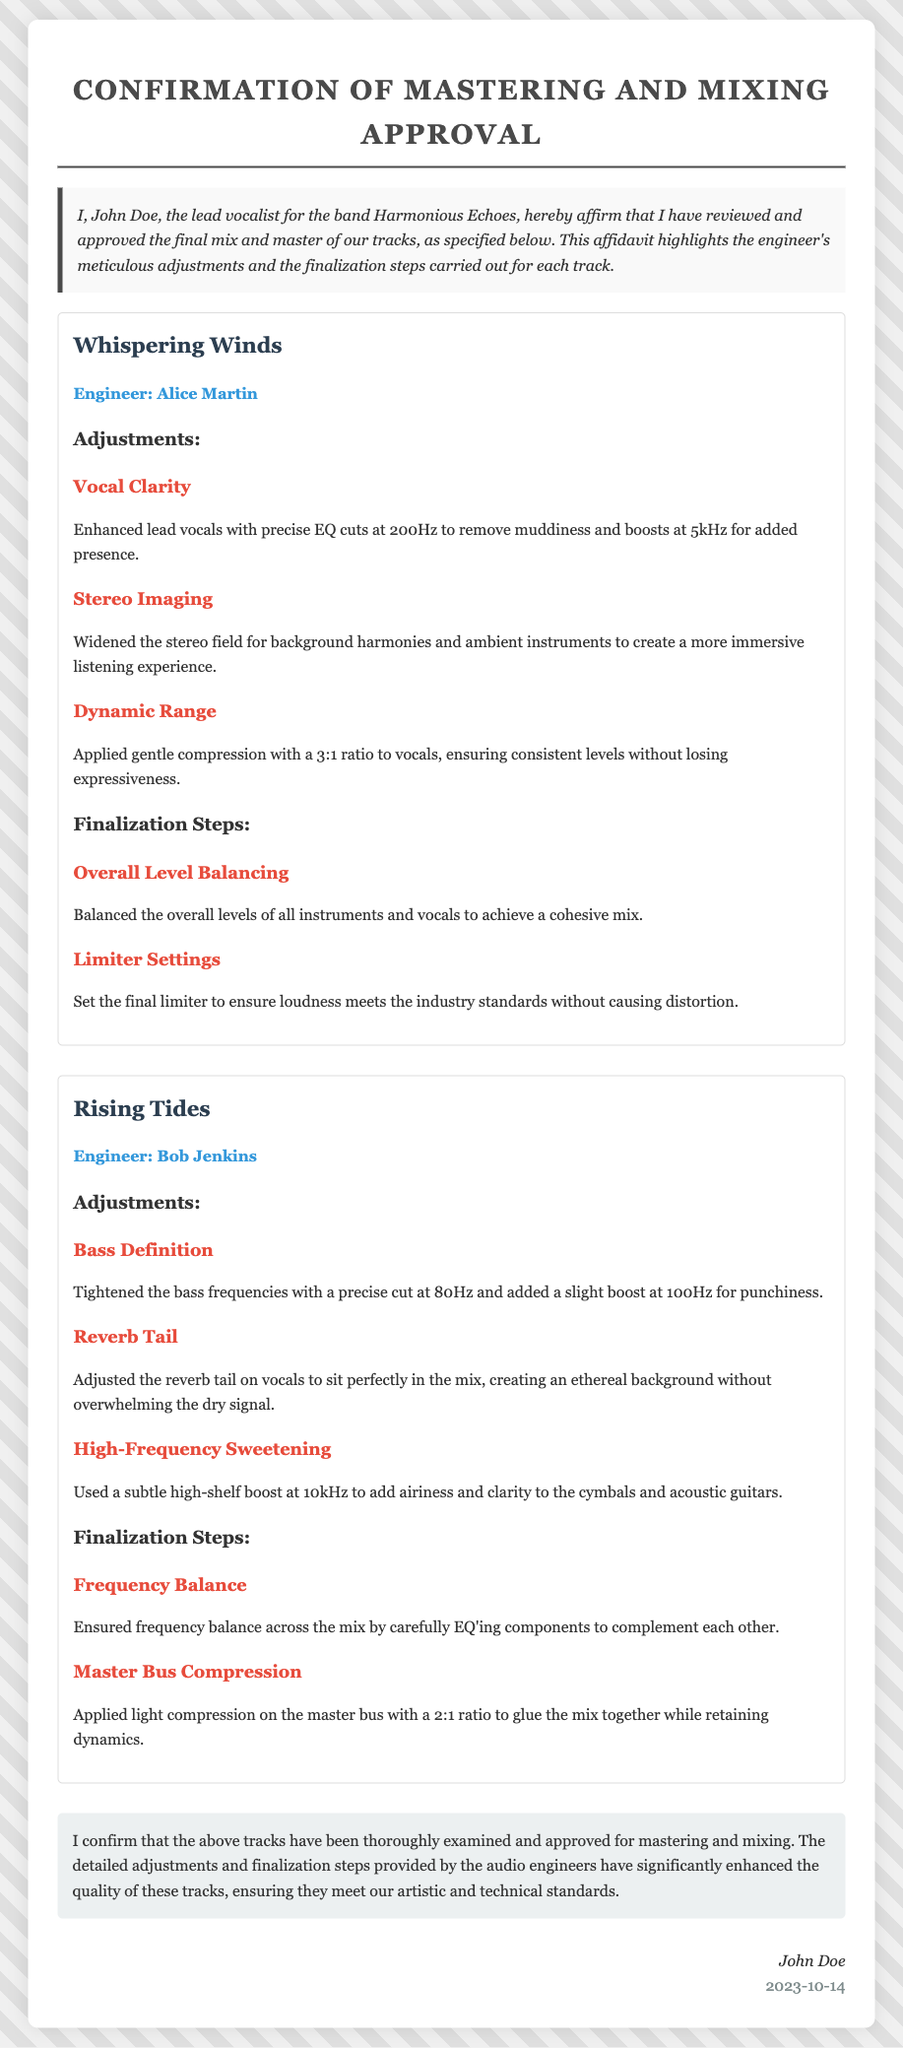What is the name of the lead vocalist? The lead vocalist is identified as John Doe in the document.
Answer: John Doe Who is the engineer for "Whispering Winds"? The document states that Alice Martin is the engineer for "Whispering Winds."
Answer: Alice Martin What adjustment was made to enhance vocal clarity? The document specifies that EQ cuts at 200Hz and boosts at 5kHz were made for vocal clarity.
Answer: EQ cuts at 200Hz and boosts at 5kHz How many finalization steps are listed for "Rising Tides"? The document lists two finalization steps for "Rising Tides."
Answer: Two What date was the affidavit signed? The signed date of the affidavit is mentioned at the bottom of the document.
Answer: 2023-10-14 What is the dynamic range adjustment used for "Whispering Winds"? The document says that gentle compression with a 3:1 ratio was applied for dynamic range.
Answer: Gentle compression with a 3:1 ratio Which track had a bass definition adjustment? The document indicates that "Rising Tides" had a bass definition adjustment.
Answer: Rising Tides What is the final confirmation statement regarding the tracks? The document includes a statement affirming that the tracks have been thoroughly examined and approved.
Answer: Thoroughly examined and approved Who confirmed the approval for mastering and mixing? John Doe, as the lead vocalist, is the one who confirmed the approval.
Answer: John Doe 